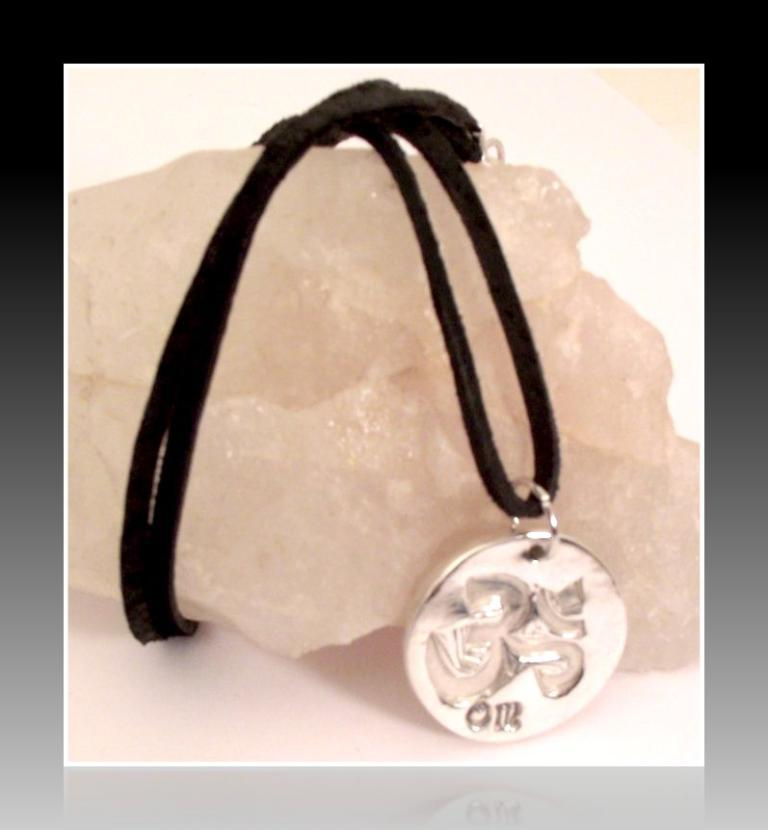What is the main object in the image? There is a locket in the image. How is the locket attached to something else? The locket is attached to a black rope. What is the color of the rope? The rope is black. Is the rope loose or tightened in the image? The black rope is tightened to an object. What type of party is being held in the image? There is no party depicted in the image; it only shows a locket attached to a black rope. What kind of board is visible in the image? There is no board present in the image. 